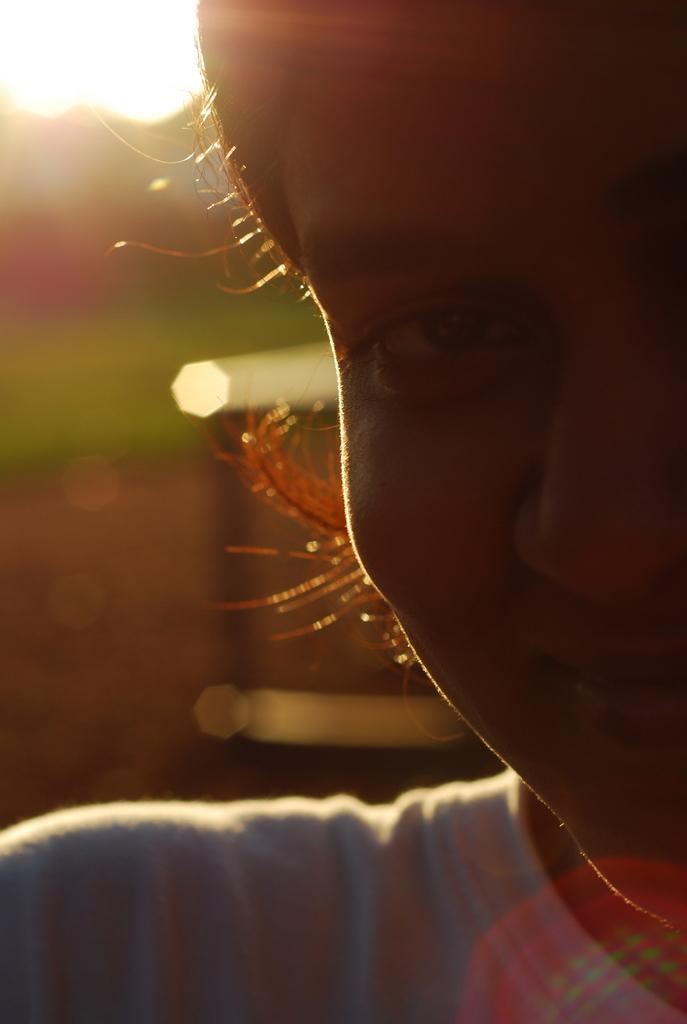Who is the main subject in the image? There is a girl in the image. What is the girl doing in the image? The girl is smiling. What is the girl wearing in the image? The girl is wearing a white t-shirt. Can you describe the background of the image? The background of the image is blurred. What can be seen in the sky in the image? The sun is visible in the image. Reasoning: Let's think step by step by following the steps to produce the conversation. We start by identifying the main subject in the image, which is the girl. Then, we describe her actions and what she is wearing. Next, we mention the background of the image and the celestial body visible in the sky. Each question is designed to elicit a specific detail about the image that is known from the provided facts. Absurd Question/Answer: How many legs does the girl have in the image? The girl has two legs in the image, but this question is irrelevant as the number of legs is not a relevant detail in the image. How many times has the girl folded her t-shirt in the image? There is no indication in the image that the girl has folded her t-shirt, and therefore this question is irrelevant and cannot be answered definitively. 